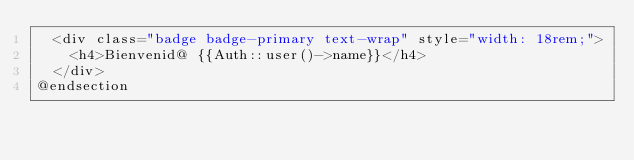Convert code to text. <code><loc_0><loc_0><loc_500><loc_500><_PHP_>	<div class="badge badge-primary text-wrap" style="width: 18rem;">
		<h4>Bienvenid@ {{Auth::user()->name}}</h4>
	</div>
@endsection
</code> 